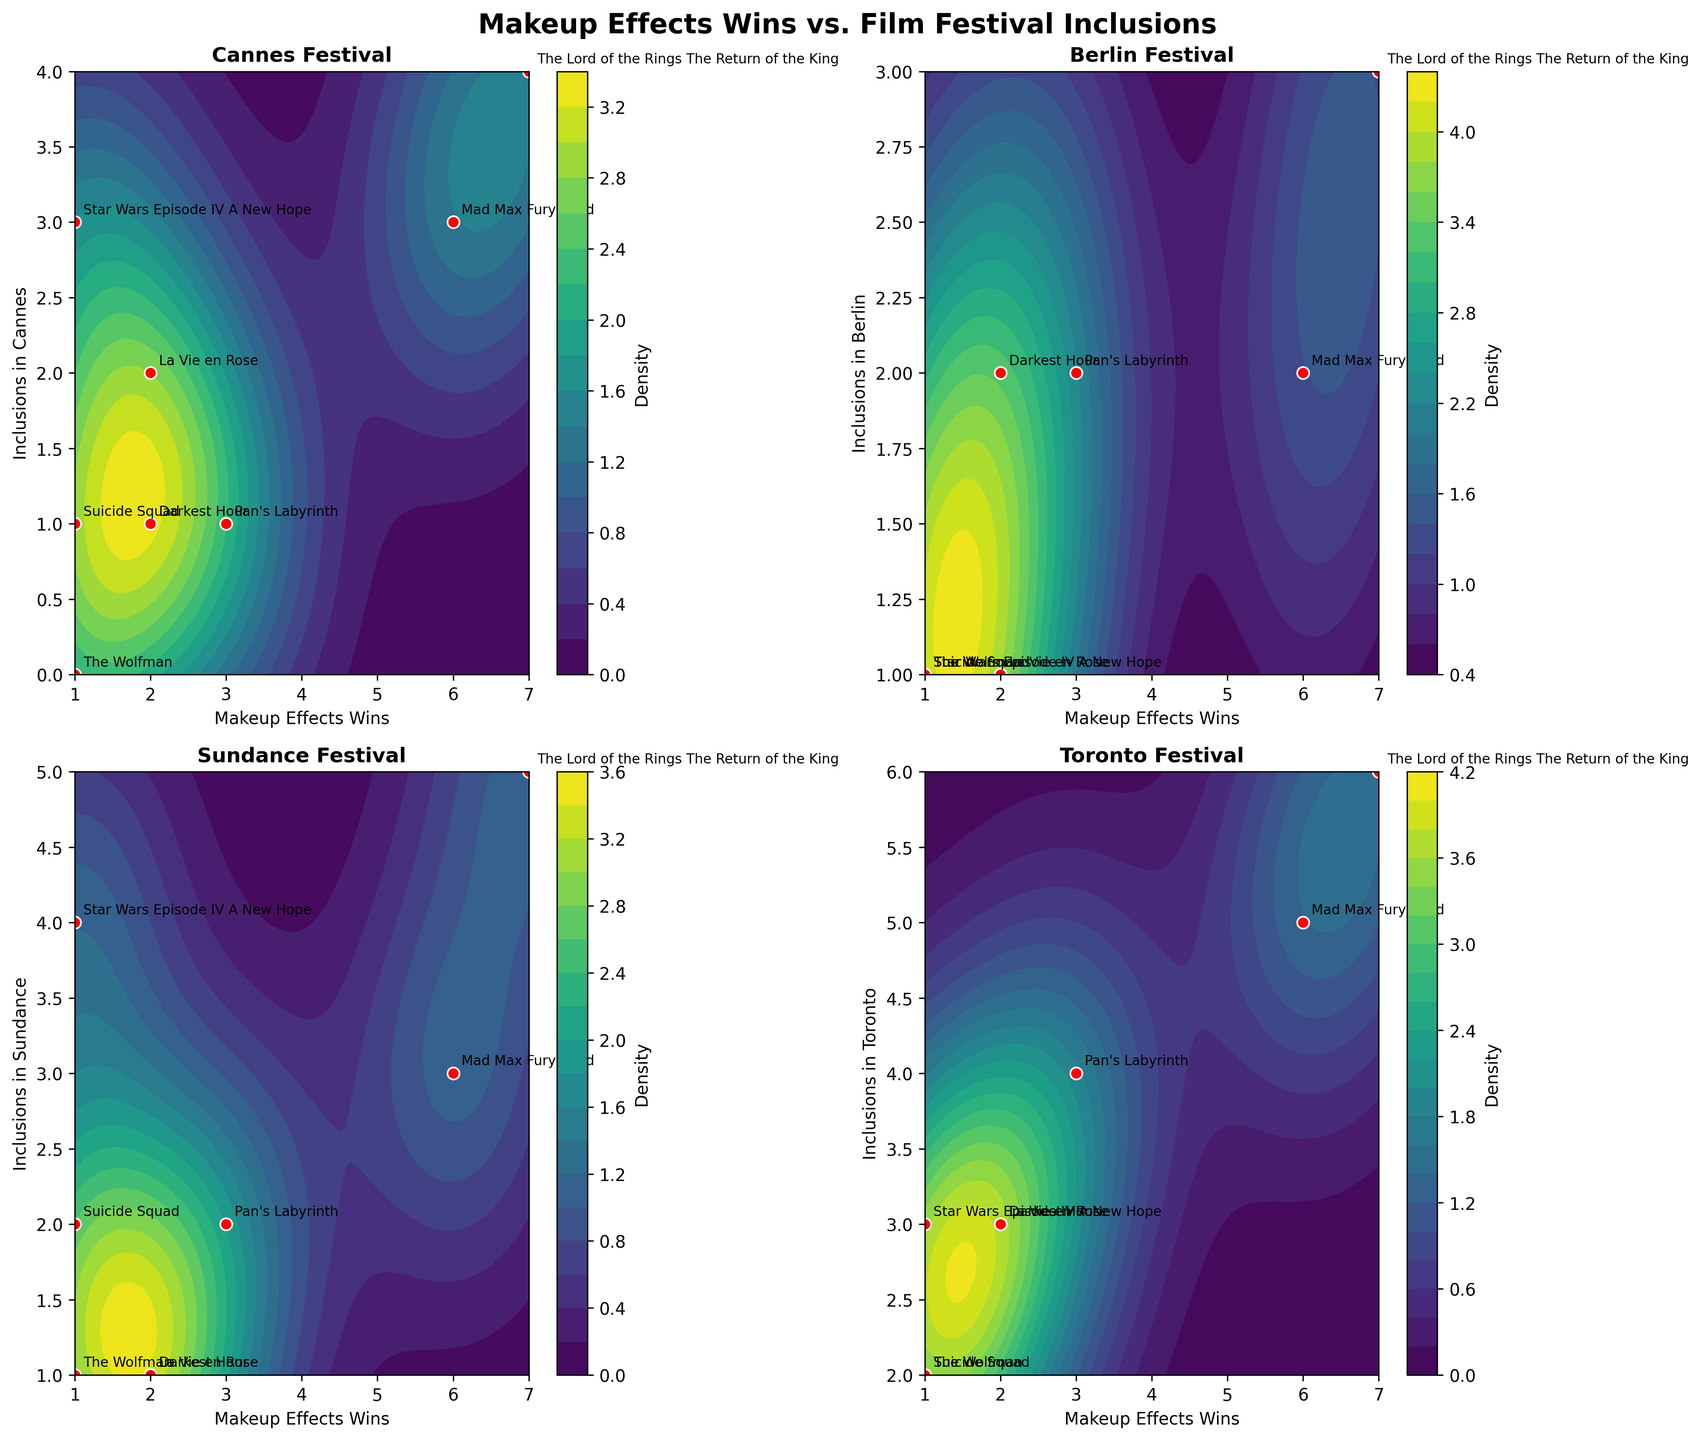What does the title of the plot indicate? The title of the plot indicates the relationship being visualized between the makeup effects wins and inclusions in various film festivals. It sets the context for interpreting the data presented in the figure.
Answer: Makeup Effects Wins vs. Film Festival Inclusions Which axis in the subplot for the Cannes Festival shows the number of makeup effects wins? For the Cannes Festival subplot, the x-axis represents the number of makeup effects wins.
Answer: x-axis How many data points are included in the subplot for the Berlin Festival? All the subplots, including the Berlin Festival one, have data points corresponding to each film listed in the data. There are 8 films, hence 8 data points.
Answer: 8 Which film had the highest number of makeup effects wins and inclusions in the Berlin Festival? The Lord of the Rings: The Return of the King had the highest number of makeup effects wins (7) and was included in the Berlin Festival (3 times).
Answer: The Lord of the Rings: The Return of the King What is the range of densities shown in the contour plots? The contour plots use varying density shades portrayed through a color gradient. Each subplot has a color bar to the side indicating density levels, which typically range from low to high. The precise value is depicted along the color bar.
Answer: Low to High Do any films have the same number of makeup effects wins and inclusions in Toronto? None of the films have the same number of makeup effects wins as their inclusions in the Toronto Festival. For example, The Lord of the Rings: The Return of the King has 7 makeup wins but 6 inclusions in Toronto.
Answer: No Which festival has the highest total inclusions across all films? By summing the inclusions for each festival: Cannes (11), Berlin (12), Sundance (19), Toronto (28). The Toronto Festival has the highest total inclusions.
Answer: Toronto Does the plot show any film that has low makeup effects wins but high inclusions in the Sundance Festival? Star Wars Episode IV: A New Hope has only 1 makeup effects win but high inclusions in Sundance (4 times).
Answer: Star Wars Episode IV: A New Hope How does the density of films in makeup wins vs. Toronto inclusions compare between regions on the plot? The Toronto subplot shows a wide spread and dense area around the mid to high ranges for both makeup wins and inclusions, indicating more films cluster in this section compared to other festivals.
Answer: Higher density mid to high range Are makeup effects largerly correlated with inclusions in any one festival? Based on the contour plots, there doesn't seem to be a clear positive correlation between makeup effects wins and inclusions in any festival as points are scattered throughout different densities.
Answer: No clear correlation 